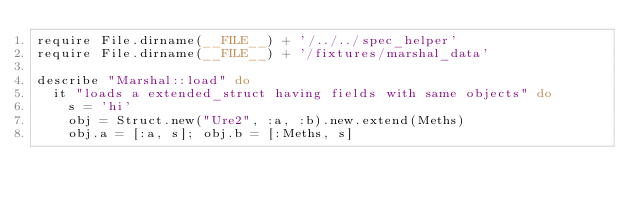Convert code to text. <code><loc_0><loc_0><loc_500><loc_500><_Ruby_>require File.dirname(__FILE__) + '/../../spec_helper'
require File.dirname(__FILE__) + '/fixtures/marshal_data'

describe "Marshal::load" do
  it "loads a extended_struct having fields with same objects" do
    s = 'hi'
    obj = Struct.new("Ure2", :a, :b).new.extend(Meths)
    obj.a = [:a, s]; obj.b = [:Meths, s]
</code> 